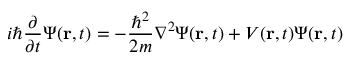<formula> <loc_0><loc_0><loc_500><loc_500>i \hbar { \frac { \partial } { \partial t } } \Psi ( r , t ) = - { \frac { \hbar { ^ } { 2 } } { 2 m } } \nabla ^ { 2 } \Psi ( r , t ) + V ( r , t ) \Psi ( r , t )</formula> 